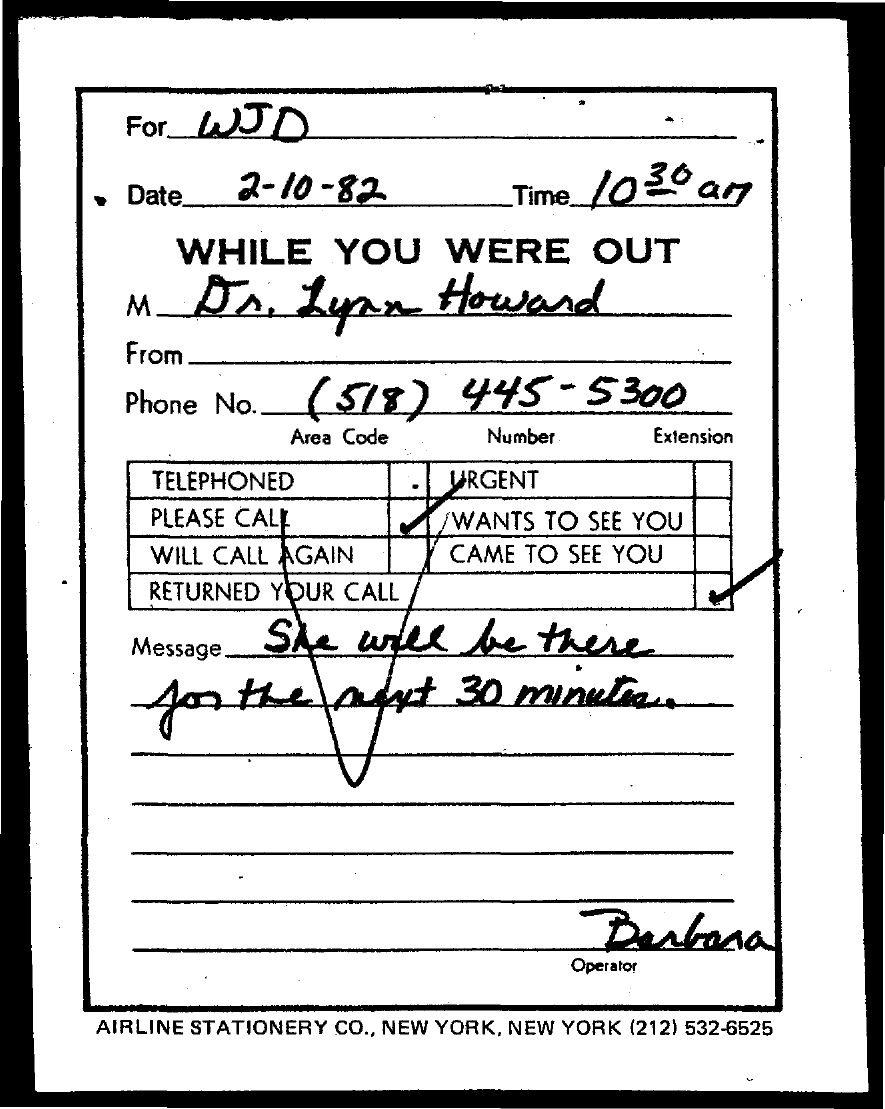Outline some significant characteristics in this image. The message contained information about the sender's question and the recipient's response, which was that the recipient will be available for the next 30 minutes. The recipient of the message is unknown. WJD. I need the contact information for Dr. Lynn Howard, specifically her phone number. The phone number I have is (518) 445-5300. The operator mentioned in the document is Barbara. 